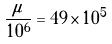Convert formula to latex. <formula><loc_0><loc_0><loc_500><loc_500>\frac { \mu } { 1 0 ^ { 6 } } = 4 9 \times 1 0 ^ { 5 }</formula> 